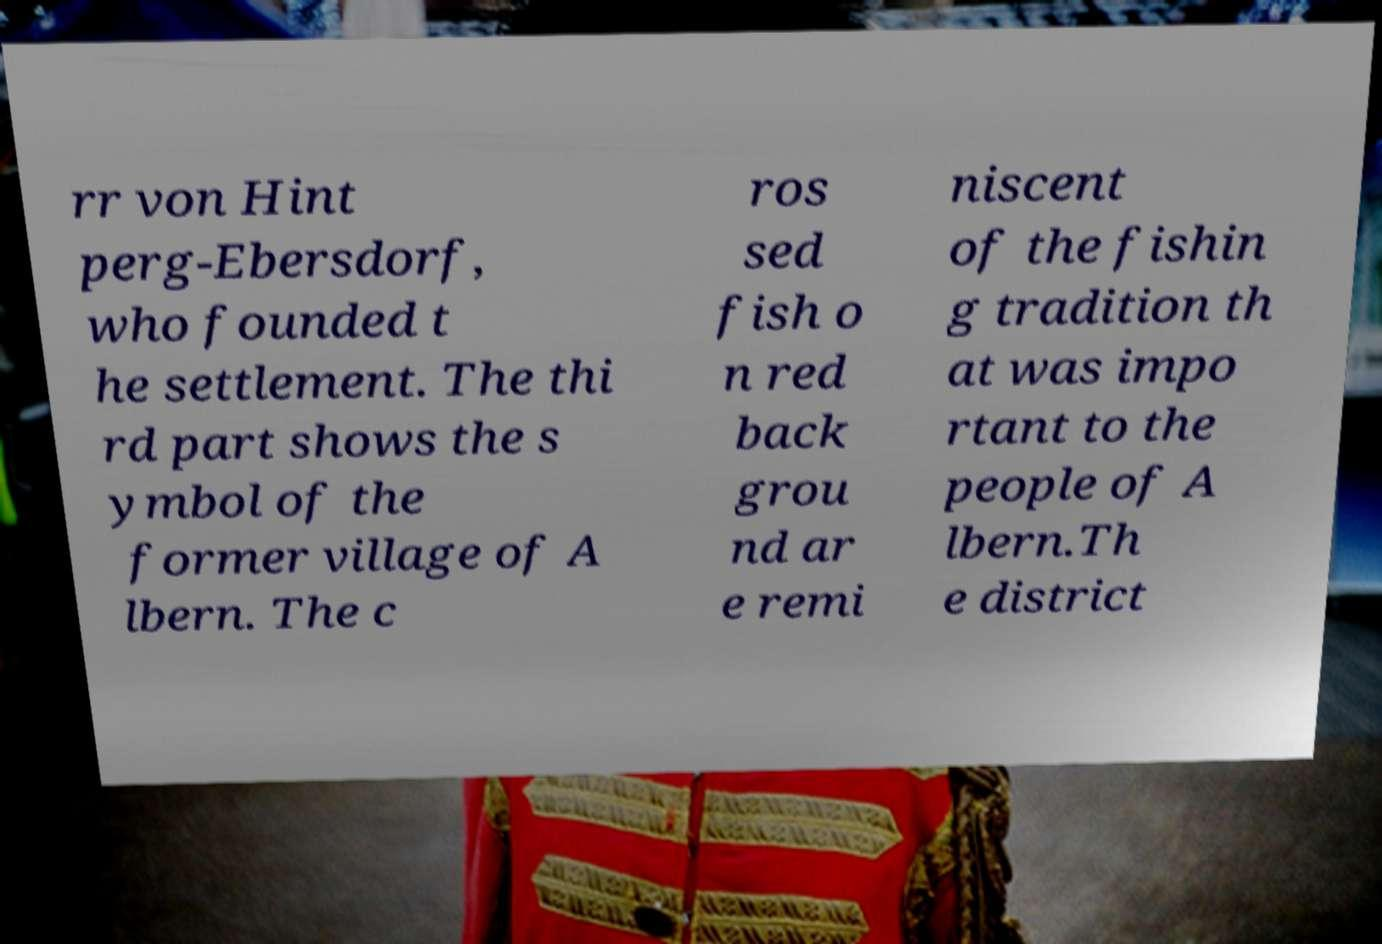Please identify and transcribe the text found in this image. rr von Hint perg-Ebersdorf, who founded t he settlement. The thi rd part shows the s ymbol of the former village of A lbern. The c ros sed fish o n red back grou nd ar e remi niscent of the fishin g tradition th at was impo rtant to the people of A lbern.Th e district 